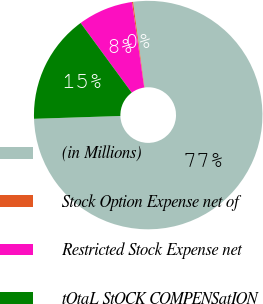Convert chart. <chart><loc_0><loc_0><loc_500><loc_500><pie_chart><fcel>(in Millions)<fcel>Stock Option Expense net of<fcel>Restricted Stock Expense net<fcel>tOtaL StOCK COMPENSatION<nl><fcel>76.59%<fcel>0.16%<fcel>7.8%<fcel>15.45%<nl></chart> 